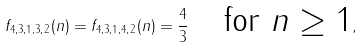<formula> <loc_0><loc_0><loc_500><loc_500>f _ { 4 , 3 , 1 , 3 , 2 } ( n ) = f _ { 4 , 3 , 1 , 4 , 2 } ( n ) = \frac { 4 } { 3 } \quad \text {for $n\geq 1$} ,</formula> 